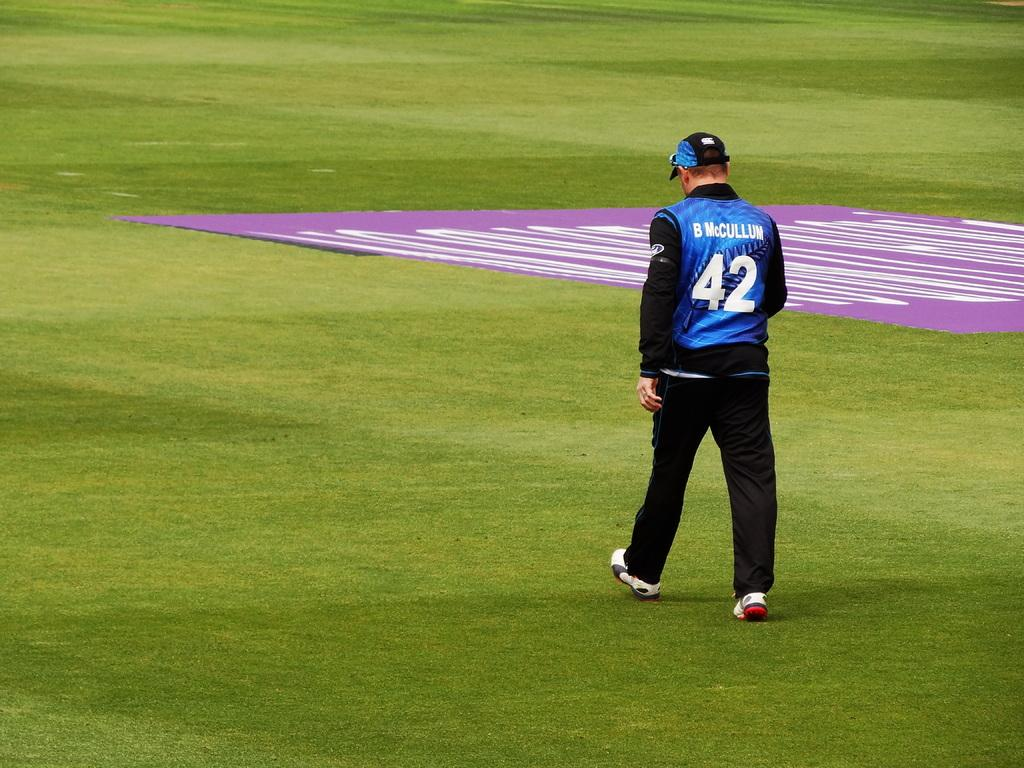<image>
Present a compact description of the photo's key features. B. McCullum walks across a green grassy field while wearing a blue jersey and black trousers. 